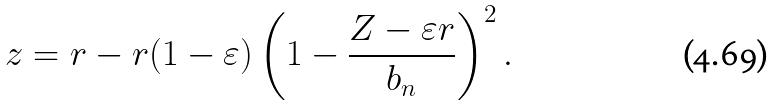<formula> <loc_0><loc_0><loc_500><loc_500>z = r - r ( 1 - \varepsilon ) \left ( 1 - \frac { Z - \varepsilon r } { b _ { n } } \right ) ^ { 2 } .</formula> 